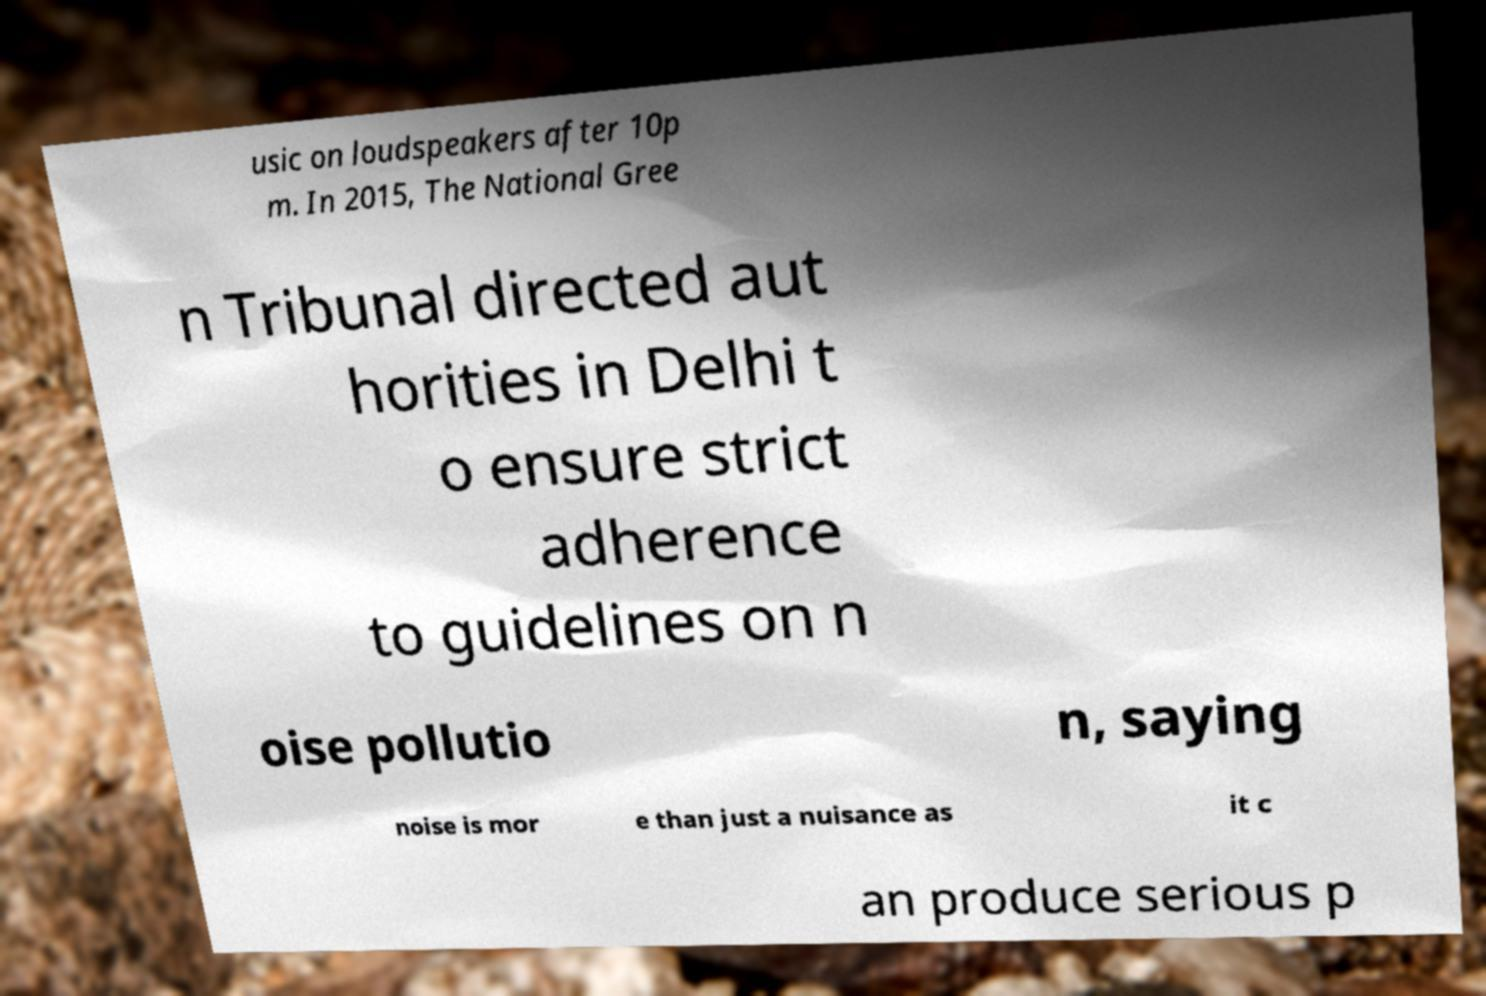What messages or text are displayed in this image? I need them in a readable, typed format. usic on loudspeakers after 10p m. In 2015, The National Gree n Tribunal directed aut horities in Delhi t o ensure strict adherence to guidelines on n oise pollutio n, saying noise is mor e than just a nuisance as it c an produce serious p 